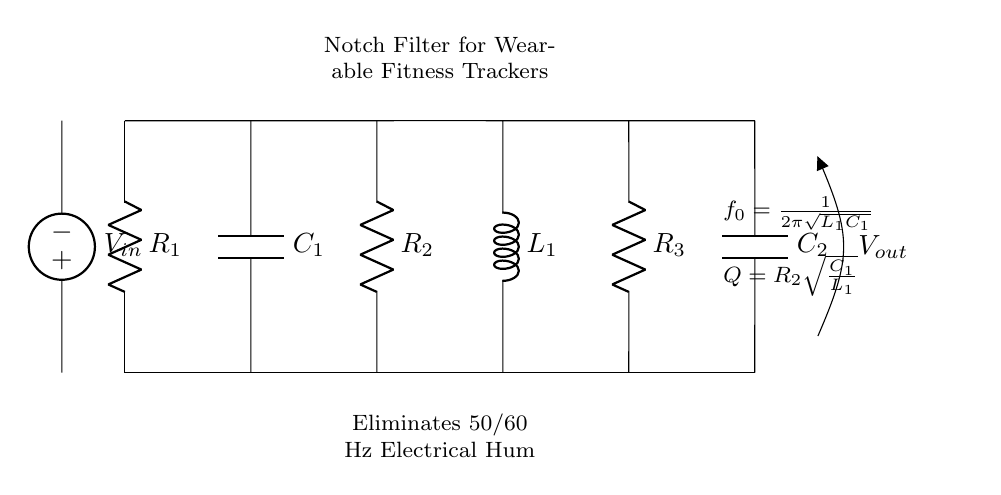What is the input voltage source? The input voltage source is labeled as V_in, and it represents the point where the incoming voltage is applied in the circuit.
Answer: V_in What is the purpose of R_2 in the circuit? R_2 is in the parallel part of the circuit and contributes to setting the quality factor Q of the notch filter, affecting the frequency selectivity and attenuation.
Answer: Quality factor Which components are used to create the notch filter? The components used to create the notch filter are resistors R_1, R_2, and R_3, capacitor C_1, capacitor C_2, and inductor L_1.
Answer: R_1, R_2, R_3, C_1, C_2, L_1 What is the resonant frequency formula shown in the circuit? The formula for the resonant frequency f_0 is given as 1 divided by 2π times the square root of L_1 and C_1. This formula determines the frequency that the circuit will attenuate.
Answer: f_0 = 1/(2π√(L_1C_1)) What does the output voltage label indicate? The output voltage label V_out indicates the point in the circuit where the filtered voltage signal can be measured after attenuation of unwanted frequencies.
Answer: V_out Why is C_2 used in this circuit? C_2 is used to help filter out high-frequency noise after the notch filter process, working along with R_3 to set the output response of the filter.
Answer: High-frequency noise filtering 